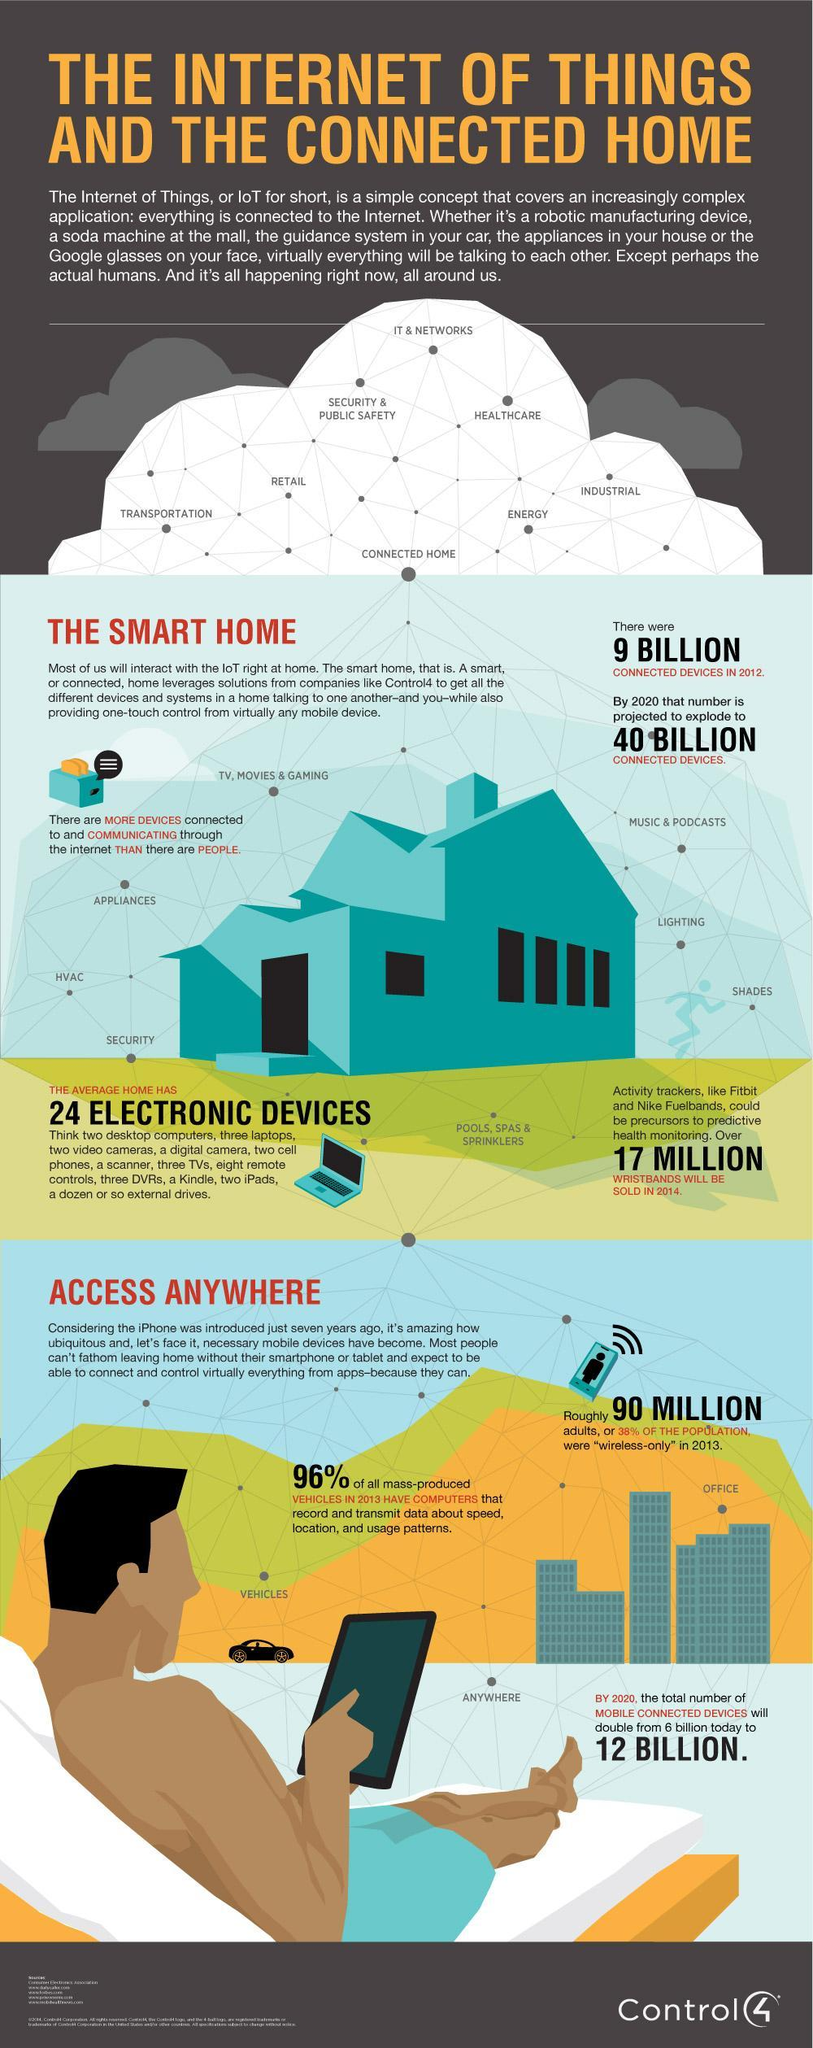What is the man holding in his hand, tablet or phone
Answer the question with a short phrase. tablet What is the colour of the toaster, blue or yellow blue How is the expectation that the connected devices will increase in billions in 2020 when compared to 2012 31 What are Fitbit and Nike Fuelbands activity tracker How much 30% of the population equal to in millions 90 